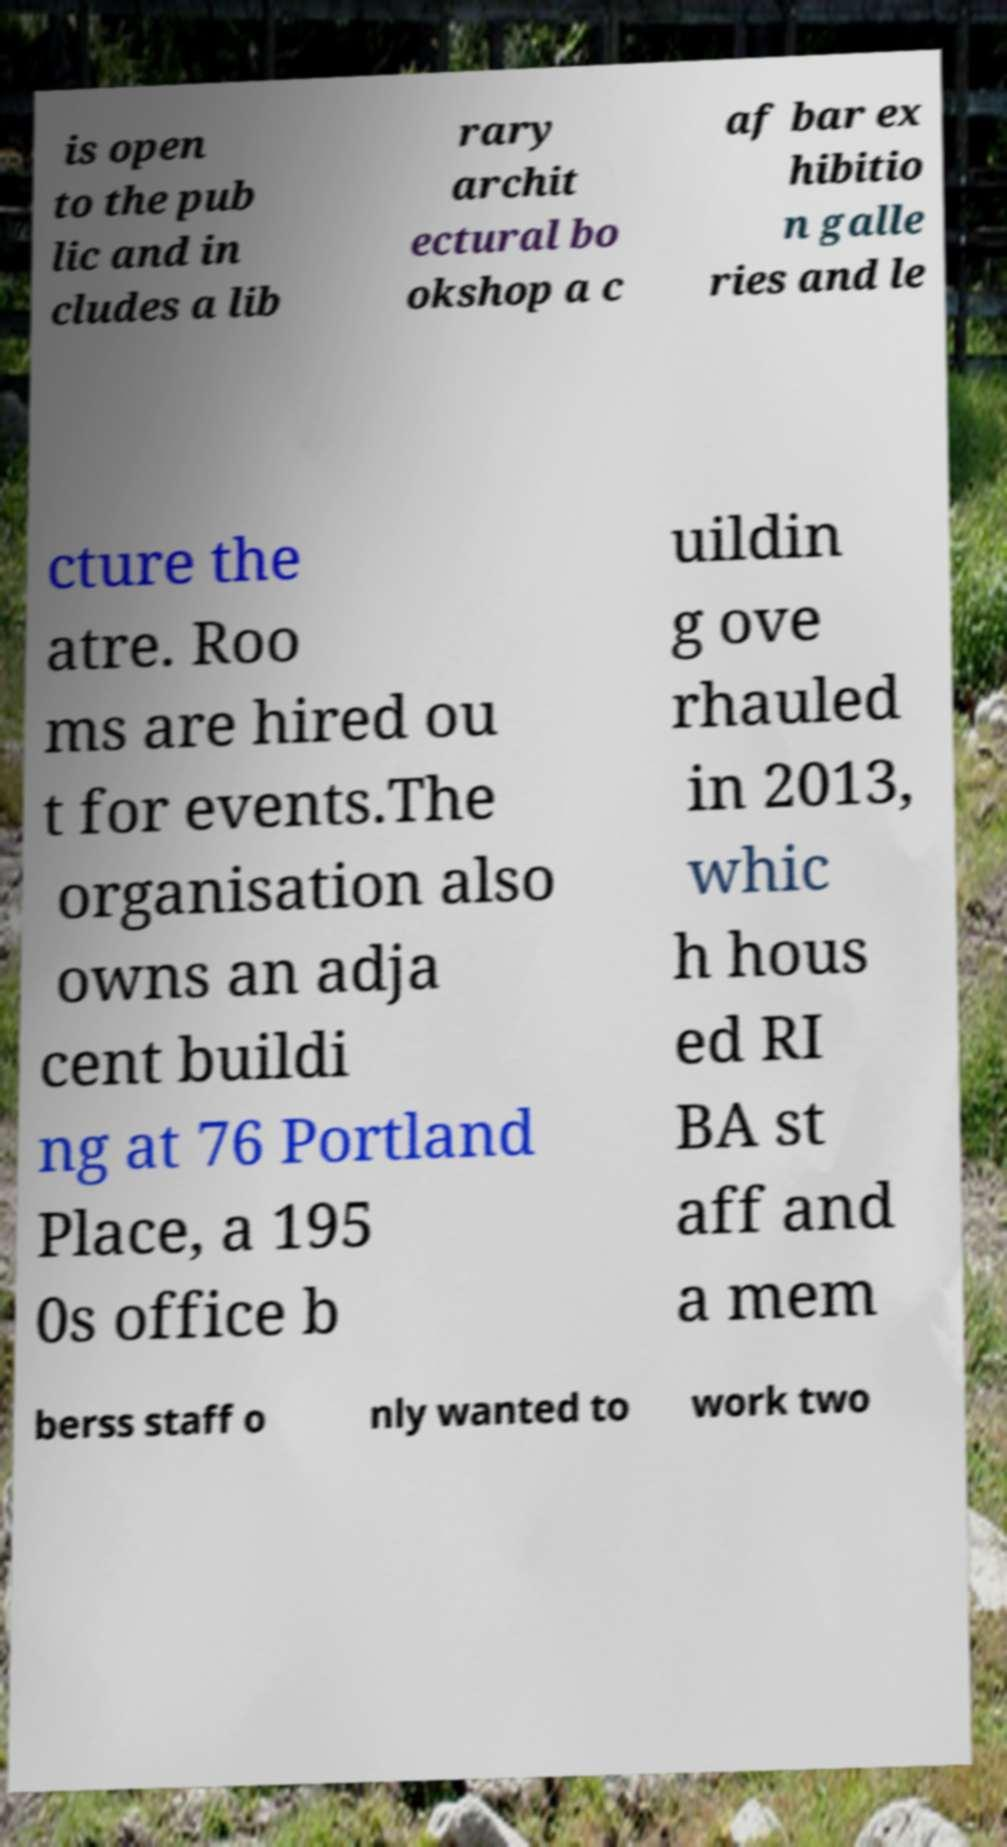Can you read and provide the text displayed in the image?This photo seems to have some interesting text. Can you extract and type it out for me? is open to the pub lic and in cludes a lib rary archit ectural bo okshop a c af bar ex hibitio n galle ries and le cture the atre. Roo ms are hired ou t for events.The organisation also owns an adja cent buildi ng at 76 Portland Place, a 195 0s office b uildin g ove rhauled in 2013, whic h hous ed RI BA st aff and a mem berss staff o nly wanted to work two 